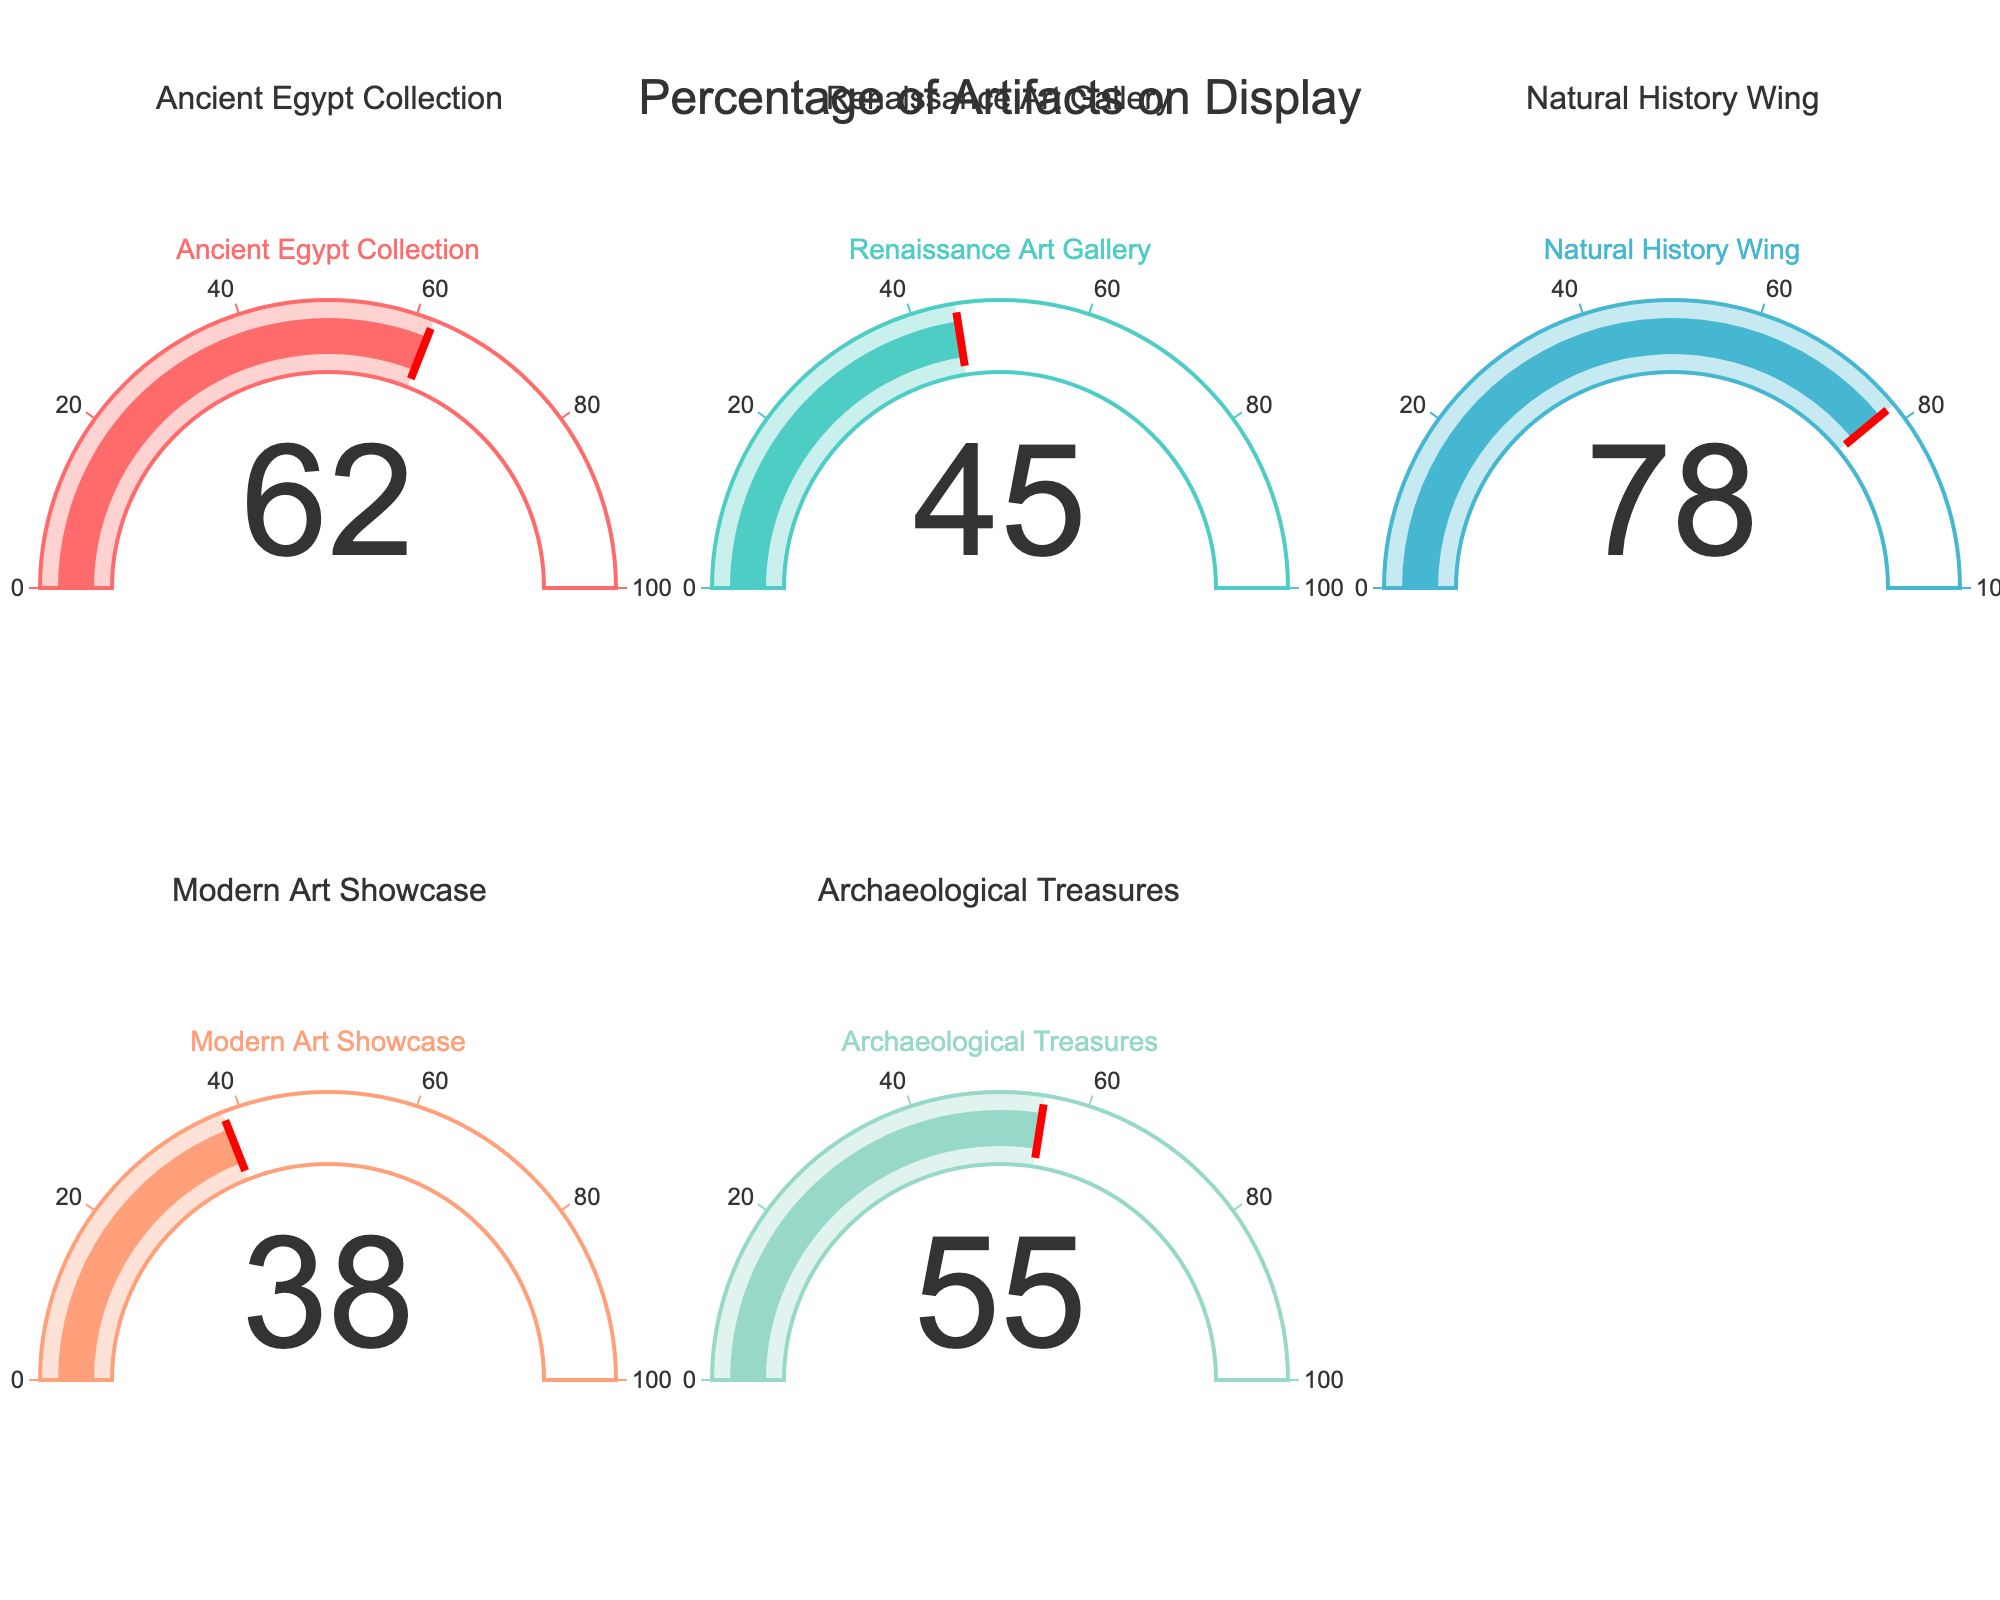What's the title of the figure? The title of the figure is always displayed at the top in a larger font than the other text. In this case, it says "Percentage of Artifacts on Display".
Answer: Percentage of Artifacts on Display Which collection has the highest percentage of artifacts on display? By examining the values shown on each gauge, the highest percentage is 78% which is associated with the Natural History Wing.
Answer: Natural History Wing What is the percentage of artifacts on display in the Modern Art Showcase? Look at the gauge associated with the Modern Art Showcase to find the single number displayed, which shows the percentage. The number displayed is 38%.
Answer: 38% How many collections have more than 50% of artifacts on display? Count the gauges that have values greater than 50. The collections with more than 50% are Ancient Egypt Collection (62%), Natural History Wing (78%), and Archaeological Treasures (55%). There are three collections.
Answer: 3 Is the percentage of artifacts on display higher in the Renaissance Art Gallery or the Archaeological Treasures? Compare the percentage values directly from the figure. The Renaissance Art Gallery has 45%, while the Archaeological Treasures have 55%.
Answer: Archaeological Treasures What's the average percentage of artifacts on display across all collections? Add all percentage values and divide by the number of collections: (62 + 45 + 78 + 38 + 55) / 5 = 278 / 5 = 55.6
Answer: 55.6 Which collection has the closest percentage of artifacts on display to 50%? Compare the values with 50 and find the smallest difference. Renaissance Art Gallery is 45% (5 away), and Archaeological Treasures is 55% (5 away). Both are equally close but Renaissance Art Gallery appears first when listed in alphabetical order.
Answer: Renaissance Art Gallery What is the difference in percentage of artifacts on display between the Ancient Egypt Collection and the Modern Art Showcase? Subtract the smaller percentage from the larger one: 62% (Ancient Egypt Collection) - 38% (Modern Art Showcase) = 24%.
Answer: 24 